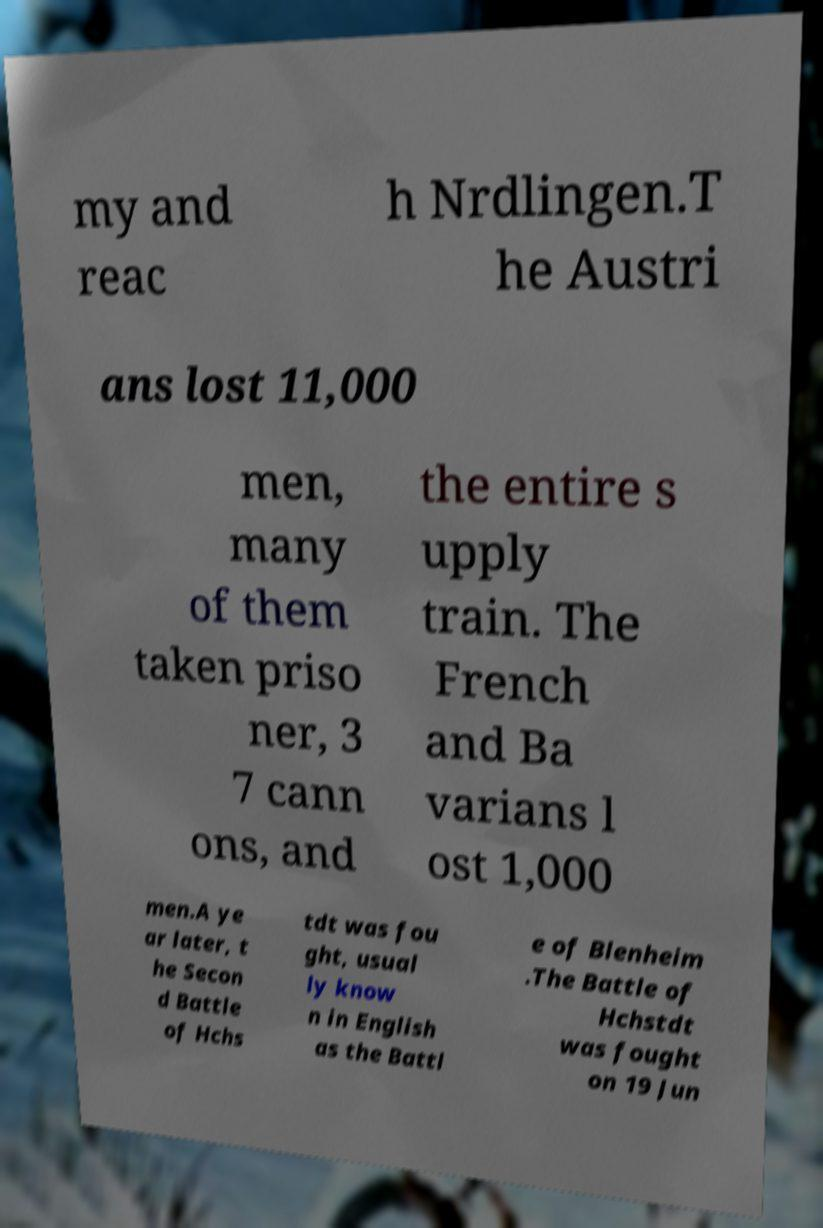Please identify and transcribe the text found in this image. my and reac h Nrdlingen.T he Austri ans lost 11,000 men, many of them taken priso ner, 3 7 cann ons, and the entire s upply train. The French and Ba varians l ost 1,000 men.A ye ar later, t he Secon d Battle of Hchs tdt was fou ght, usual ly know n in English as the Battl e of Blenheim .The Battle of Hchstdt was fought on 19 Jun 